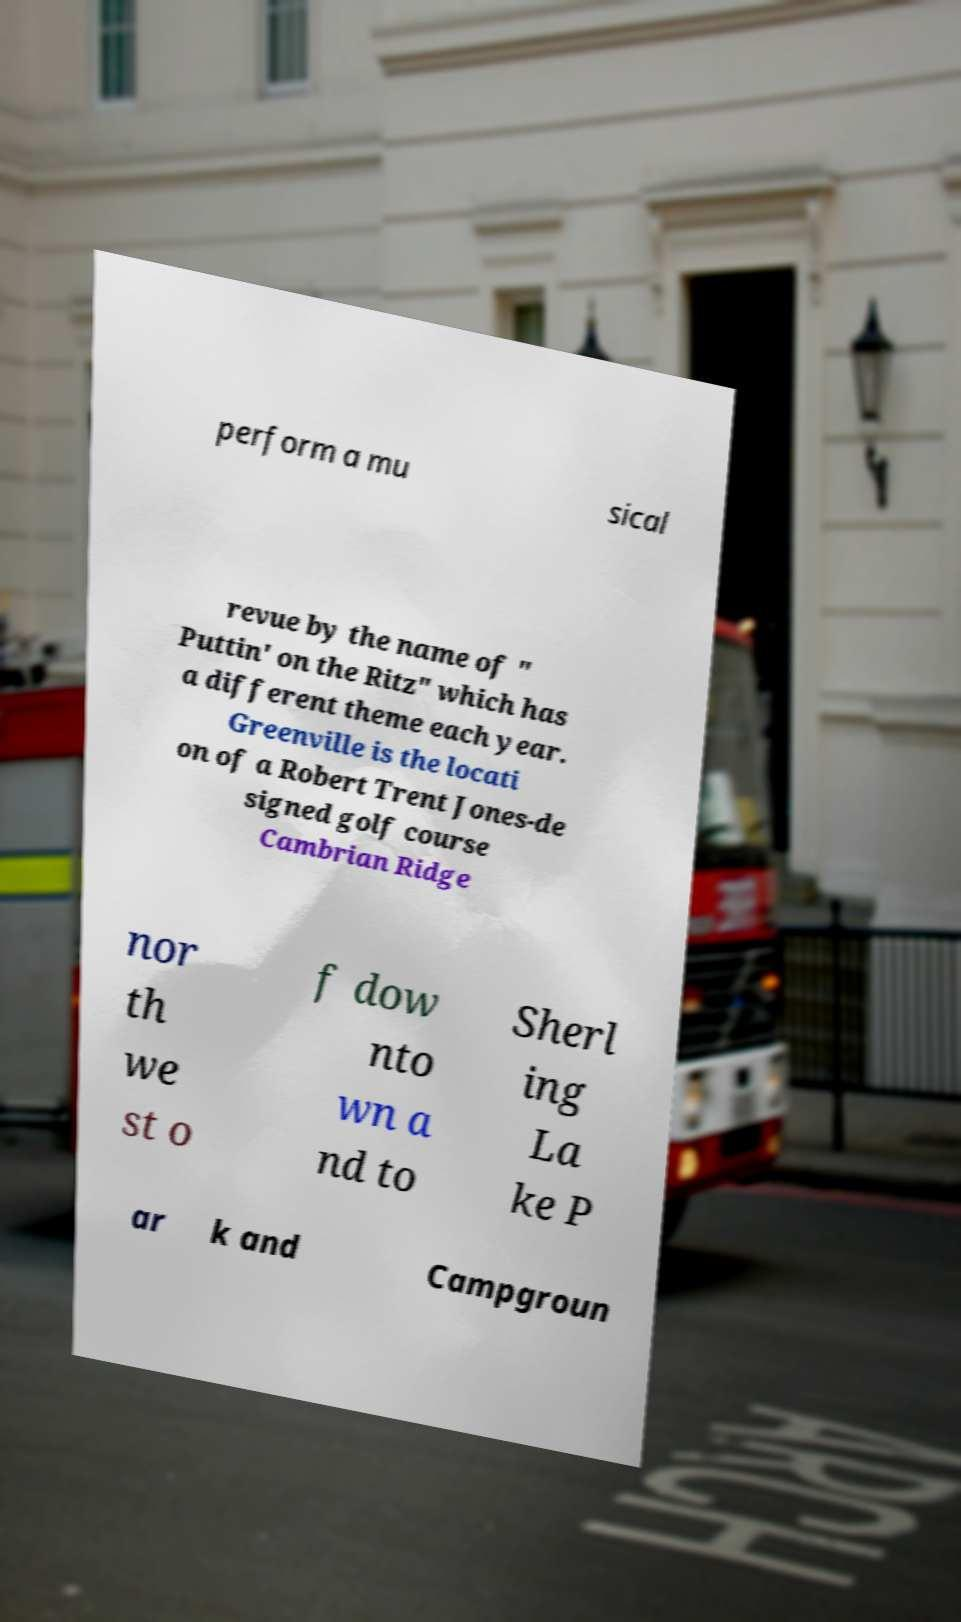There's text embedded in this image that I need extracted. Can you transcribe it verbatim? perform a mu sical revue by the name of " Puttin' on the Ritz" which has a different theme each year. Greenville is the locati on of a Robert Trent Jones-de signed golf course Cambrian Ridge nor th we st o f dow nto wn a nd to Sherl ing La ke P ar k and Campgroun 